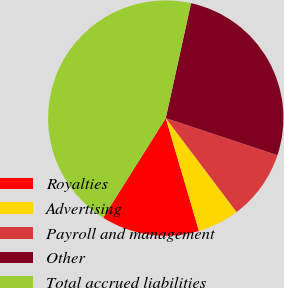Convert chart to OTSL. <chart><loc_0><loc_0><loc_500><loc_500><pie_chart><fcel>Royalties<fcel>Advertising<fcel>Payroll and management<fcel>Other<fcel>Total accrued liabilities<nl><fcel>13.49%<fcel>5.73%<fcel>9.61%<fcel>26.66%<fcel>44.51%<nl></chart> 